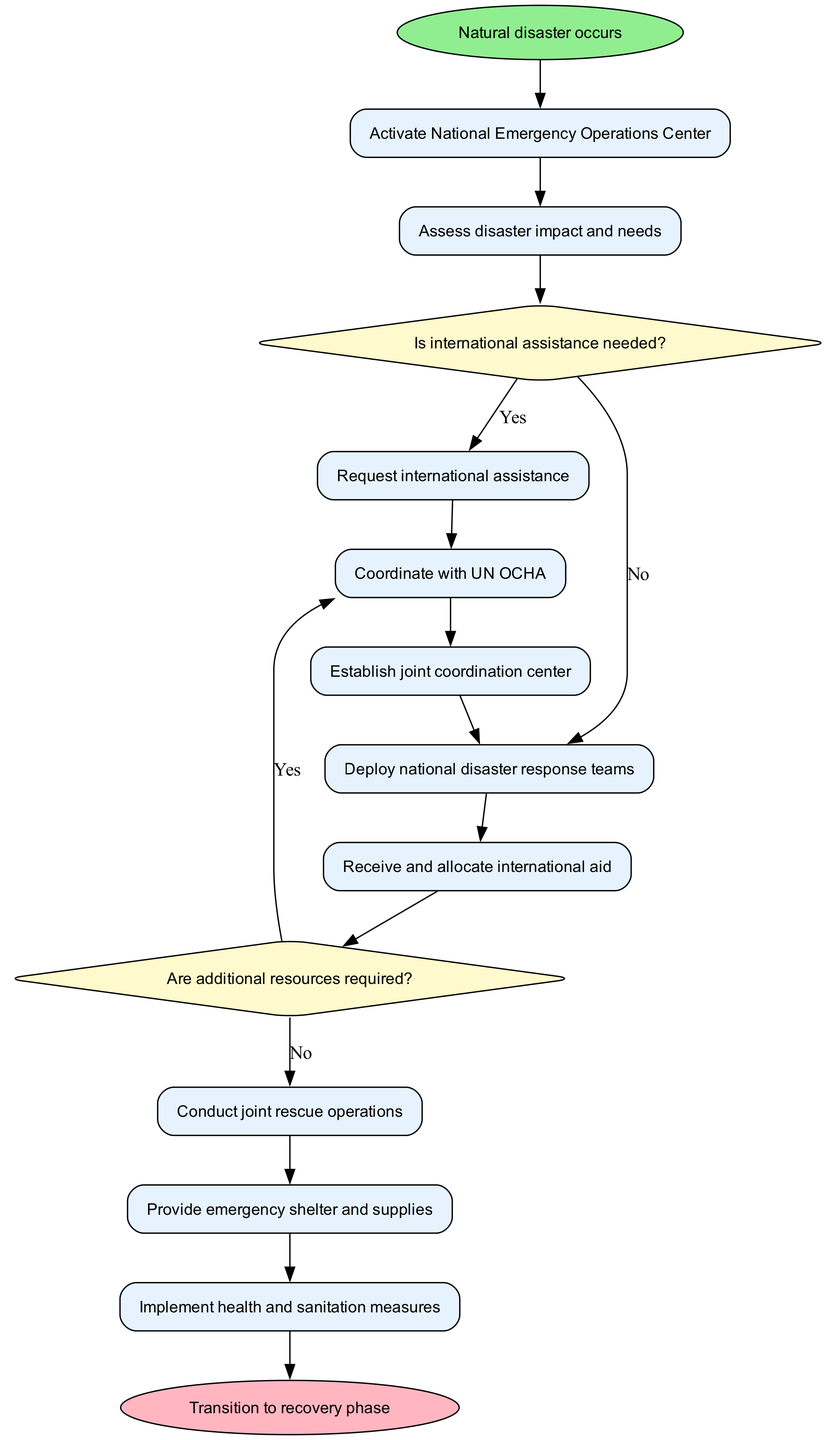What is the starting node of the diagram? The starting node, labeled 'Natural disaster occurs', indicates where the process begins.
Answer: Natural disaster occurs How many activities are listed in the diagram? By counting the activities provided in the data, we find there are a total of ten activities.
Answer: 10 What happens after assessing disaster impact and needs if international assistance is needed? If international assistance is needed, the next step is to 'Request international assistance' as indicated by the outgoing edge.
Answer: Request international assistance What decision must be made after receiving and allocating international aid? After receiving and allocating international aid, the decision to be made is 'Are additional resources required?' as shown in the diagram.
Answer: Are additional resources required? Which activity follows the decision that additional resources are not required? If the decision is that no additional resources are needed, the diagram shows to 'Continue current operations' next.
Answer: Continue current operations What is the end node of the diagram? The end node, which is where the process concludes, is labeled 'Transition to recovery phase'.
Answer: Transition to recovery phase What is the conditional decision related to requesting international assistance? The conditional decision related to requesting international assistance is 'Is international assistance needed?'.
Answer: Is international assistance needed? What is the next step after establishing a joint coordination center? The next activity after establishing a joint coordination center is to 'Deploy national disaster response teams' as shown by the directed edges in the diagram.
Answer: Deploy national disaster response teams How does the diagram connect the activities and decisions? The diagram connects activities and decisions through directed edges that indicate the flow of operations, showcasing how one leads to another based on outcomes of decisions.
Answer: Directed edges indicate flow 